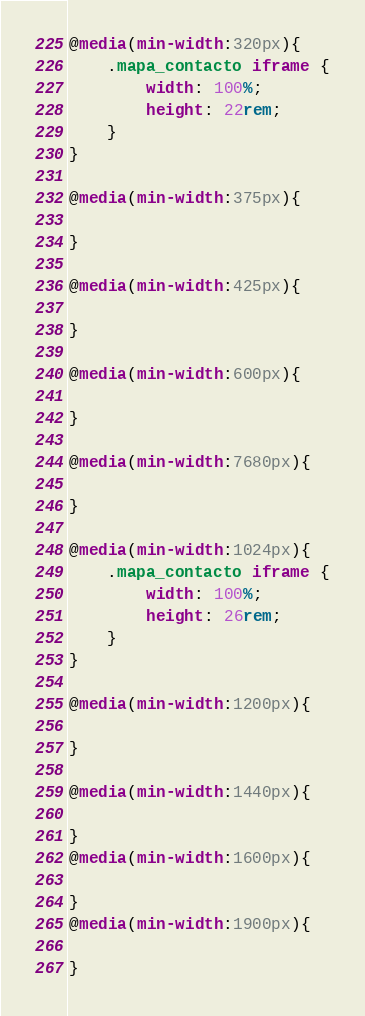<code> <loc_0><loc_0><loc_500><loc_500><_CSS_>
@media(min-width:320px){
    .mapa_contacto iframe {
        width: 100%;
        height: 22rem;
    }
}

@media(min-width:375px){
    
}

@media(min-width:425px){
    
}

@media(min-width:600px){
    
}

@media(min-width:7680px){
    
}

@media(min-width:1024px){
    .mapa_contacto iframe {
        width: 100%;
        height: 26rem;
    }
}

@media(min-width:1200px){
    
}

@media(min-width:1440px){
    
}
@media(min-width:1600px){
    
}
@media(min-width:1900px){
    
}
</code> 